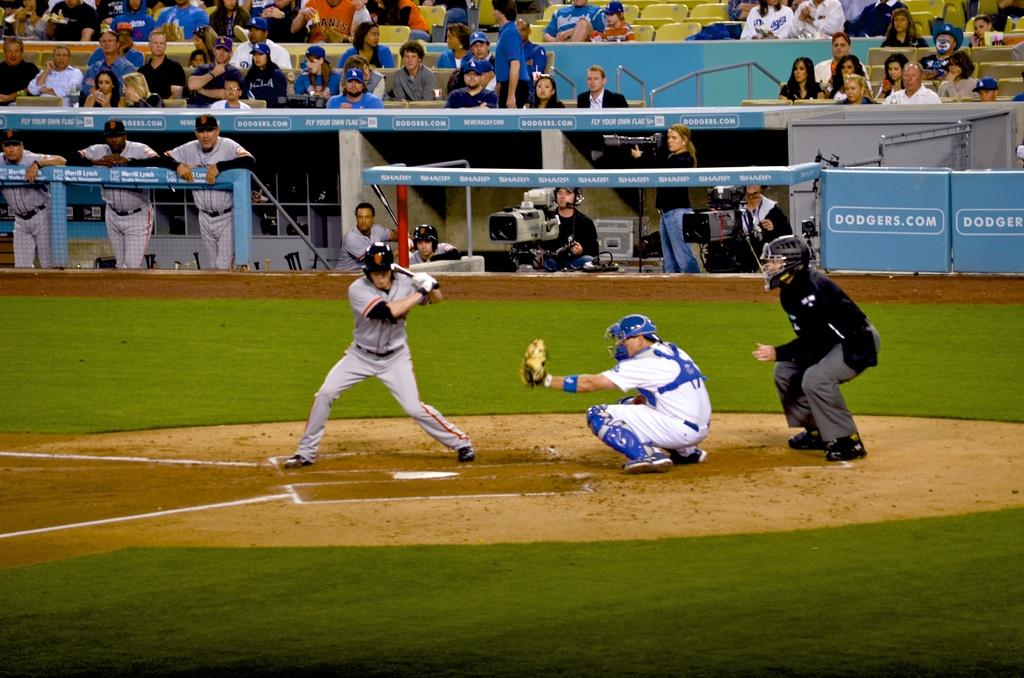Provide a one-sentence caption for the provided image. a player waiting for a pitch that has SF on his helmet. 